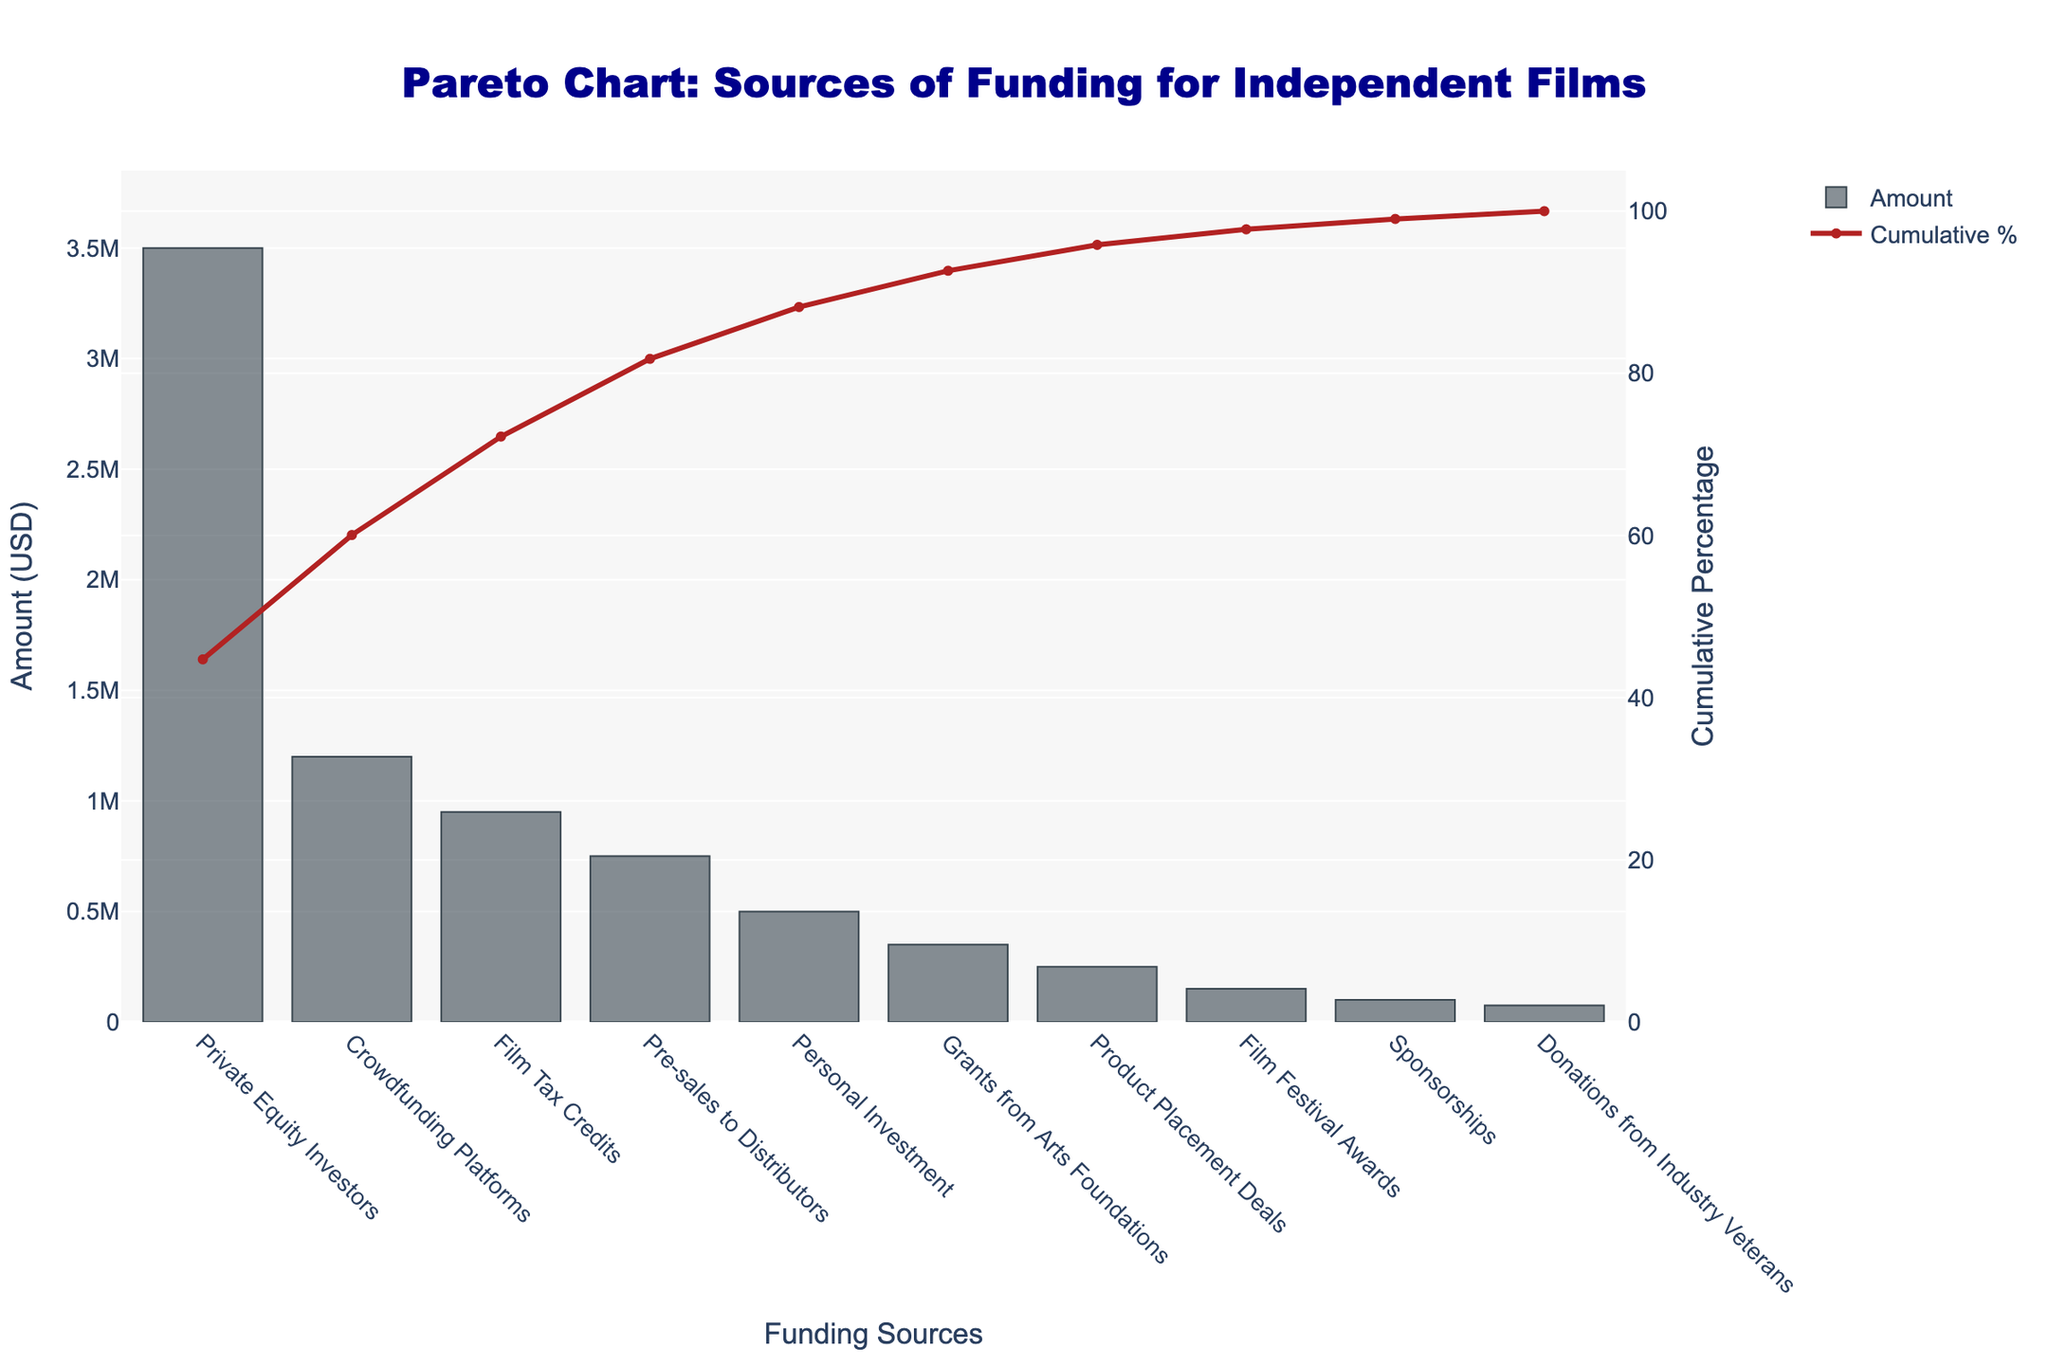How many funding sources are listed in the figure? Count the number of unique funding sources on the x-axis of the bar chart.
Answer: 10 Which funding source contributes the highest amount of funding? Identify the first bar in the descending-ordered list of funding sources in the bar chart.
Answer: Private Equity Investors What is the cumulative percentage for the top three funding sources combined? Add the cumulative percentages for "Private Equity Investors", "Crowdfunding Platforms", and "Film Tax Credits" found on the line chart.
Answer: ~76.0% By how much does the amount from Crowdfunding Platforms exceed that from Pre-sales to Distributors? Subtract the amount for Pre-sales to Distributors from the amount for Crowdfunding Platforms.
Answer: 450,000 USD What is the total amount of funding shown in the chart? Sum the amounts of all funding sources listed in the bar chart.
Answer: 7,750,000 USD Which funding sources contribute to achieving a cumulative percentage of at least 80%? Identify the funding sources in order until the cumulative percentage on the line chart reaches 80%.
Answer: Private Equity Investors, Crowdfunding Platforms, Film Tax Credits, Pre-sales to Distributors, Personal Investment How much more funding is received from Personal Investment compared to Donations from Industry Veterans? Subtract the amount for Donations from Industry Veterans from the amount for Personal Investment.
Answer: 425,000 USD What percentage of total funding is contributed by Film Tax Credits? Divide the amount for Film Tax Credits by the total amount of funding, then multiply by 100.
Answer: ~12.26% Which funding source is the fourth largest contributor? Identify the fourth bar in the descending-ordered list of funding sources in the bar chart.
Answer: Pre-sales to Distributors What is the order of funding sources from highest to lowest contribution? List the funding sources as they appear from left to right in the bar chart.
Answer: Private Equity Investors, Crowdfunding Platforms, Film Tax Credits, Pre-sales to Distributors, Personal Investment, Grants from Arts Foundations, Product Placement Deals, Film Festival Awards, Sponsorships, Donations from Industry Veterans 